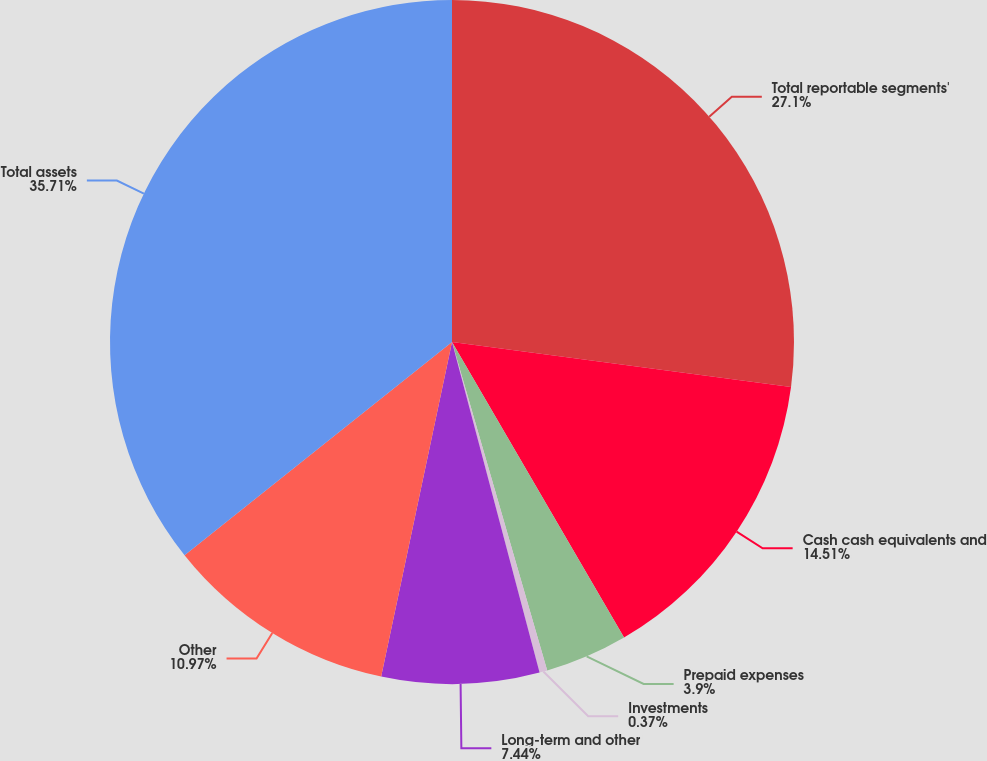Convert chart. <chart><loc_0><loc_0><loc_500><loc_500><pie_chart><fcel>Total reportable segments'<fcel>Cash cash equivalents and<fcel>Prepaid expenses<fcel>Investments<fcel>Long-term and other<fcel>Other<fcel>Total assets<nl><fcel>27.1%<fcel>14.51%<fcel>3.9%<fcel>0.37%<fcel>7.44%<fcel>10.97%<fcel>35.71%<nl></chart> 